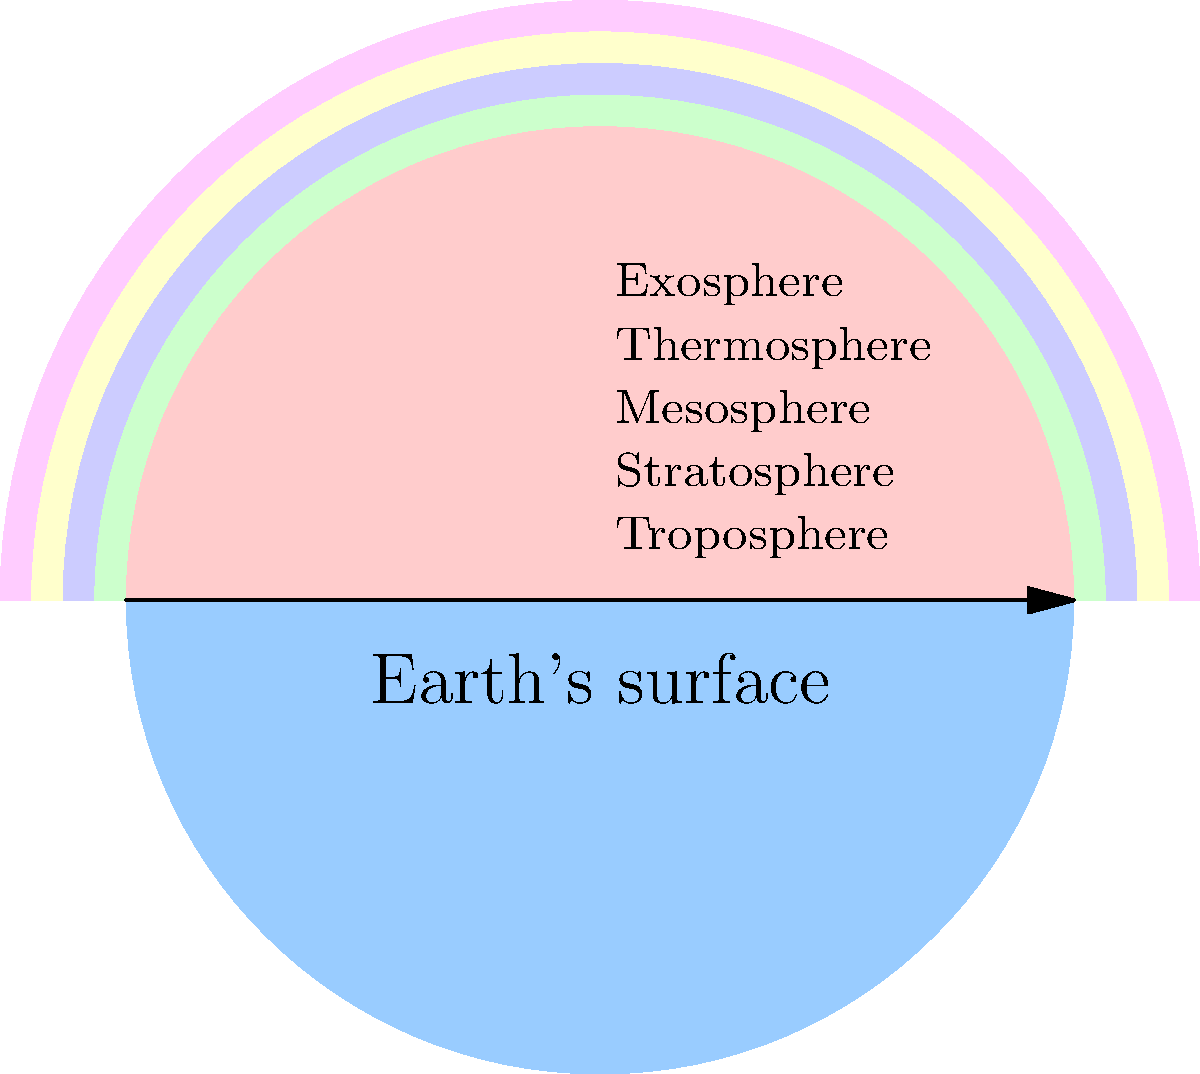In your narrative for the science fair presentation on Earth's atmosphere, you need to describe the layers accurately. Using the cross-sectional diagram provided, identify the correct order of the atmospheric layers from the Earth's surface outward. How would you creatively explain the significance of this layered structure in your narrative? To answer this question and create an engaging narrative, follow these steps:

1. Observe the diagram: The cross-sectional view shows the Earth's atmosphere divided into distinct layers.

2. Identify the layers: Starting from the Earth's surface (bottom) and moving outward (upward), the layers are labeled as:
   a) Troposphere
   b) Stratosphere
   c) Mesosphere
   d) Thermosphere
   e) Exosphere

3. Understand the significance:
   - Troposphere: Where weather occurs and life thrives
   - Stratosphere: Contains the ozone layer, protecting Earth from harmful UV radiation
   - Mesosphere: Where meteors burn up, creating "shooting stars"
   - Thermosphere: Where auroras occur and satellites orbit
   - Exosphere: Transitions to space, extremely thin atmosphere

4. Creative narrative approach:
   - Imagine the atmosphere as a protective blanket for Earth
   - Each layer has a unique role, like characters in a story
   - Describe how these layers interact and protect life on Earth
   - Use metaphors or analogies to make the concept more relatable (e.g., layers of a cake or onion)

5. Emphasize the interconnectedness of the layers and their importance for maintaining Earth's habitability.

By explaining the layers in this order and highlighting their significance, you can create an engaging and informative narrative for the science fair presentation.
Answer: Troposphere, Stratosphere, Mesosphere, Thermosphere, Exosphere; each layer serves a unique protective function for Earth. 